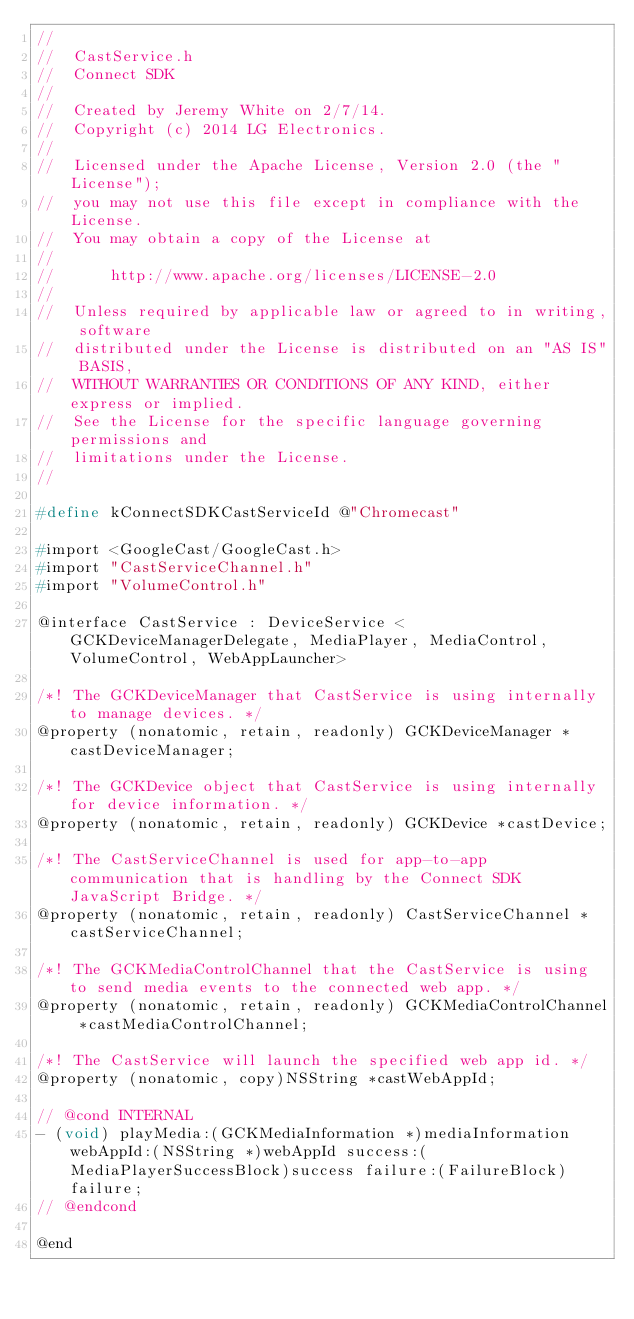Convert code to text. <code><loc_0><loc_0><loc_500><loc_500><_C_>//
//  CastService.h
//  Connect SDK
//
//  Created by Jeremy White on 2/7/14.
//  Copyright (c) 2014 LG Electronics.
//
//  Licensed under the Apache License, Version 2.0 (the "License");
//  you may not use this file except in compliance with the License.
//  You may obtain a copy of the License at
//
//      http://www.apache.org/licenses/LICENSE-2.0
//
//  Unless required by applicable law or agreed to in writing, software
//  distributed under the License is distributed on an "AS IS" BASIS,
//  WITHOUT WARRANTIES OR CONDITIONS OF ANY KIND, either express or implied.
//  See the License for the specific language governing permissions and
//  limitations under the License.
//

#define kConnectSDKCastServiceId @"Chromecast"

#import <GoogleCast/GoogleCast.h>
#import "CastServiceChannel.h"
#import "VolumeControl.h"

@interface CastService : DeviceService <GCKDeviceManagerDelegate, MediaPlayer, MediaControl, VolumeControl, WebAppLauncher>

/*! The GCKDeviceManager that CastService is using internally to manage devices. */
@property (nonatomic, retain, readonly) GCKDeviceManager *castDeviceManager;

/*! The GCKDevice object that CastService is using internally for device information. */
@property (nonatomic, retain, readonly) GCKDevice *castDevice;

/*! The CastServiceChannel is used for app-to-app communication that is handling by the Connect SDK JavaScript Bridge. */
@property (nonatomic, retain, readonly) CastServiceChannel *castServiceChannel;

/*! The GCKMediaControlChannel that the CastService is using to send media events to the connected web app. */
@property (nonatomic, retain, readonly) GCKMediaControlChannel *castMediaControlChannel;

/*! The CastService will launch the specified web app id. */
@property (nonatomic, copy)NSString *castWebAppId;

// @cond INTERNAL
- (void) playMedia:(GCKMediaInformation *)mediaInformation webAppId:(NSString *)webAppId success:(MediaPlayerSuccessBlock)success failure:(FailureBlock)failure;
// @endcond

@end
</code> 